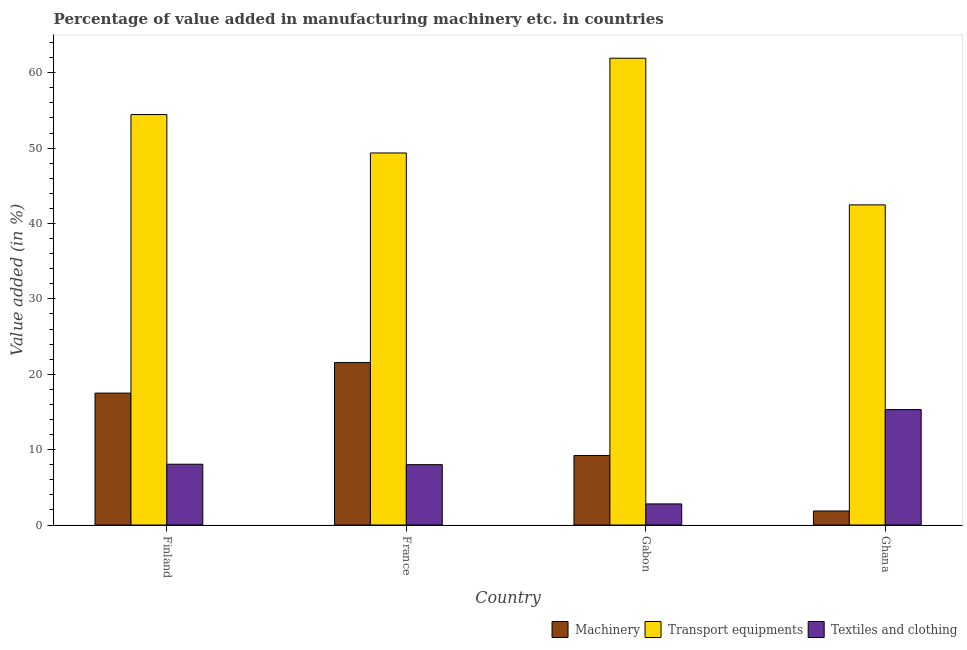Are the number of bars on each tick of the X-axis equal?
Make the answer very short. Yes. How many bars are there on the 2nd tick from the left?
Your answer should be compact. 3. How many bars are there on the 4th tick from the right?
Give a very brief answer. 3. What is the label of the 4th group of bars from the left?
Provide a succinct answer. Ghana. In how many cases, is the number of bars for a given country not equal to the number of legend labels?
Make the answer very short. 0. What is the value added in manufacturing transport equipments in Finland?
Offer a very short reply. 54.45. Across all countries, what is the maximum value added in manufacturing transport equipments?
Your answer should be very brief. 61.93. Across all countries, what is the minimum value added in manufacturing machinery?
Offer a very short reply. 1.86. In which country was the value added in manufacturing machinery maximum?
Keep it short and to the point. France. In which country was the value added in manufacturing machinery minimum?
Provide a short and direct response. Ghana. What is the total value added in manufacturing textile and clothing in the graph?
Your answer should be compact. 34.19. What is the difference between the value added in manufacturing machinery in Finland and that in Gabon?
Offer a very short reply. 8.27. What is the difference between the value added in manufacturing machinery in Gabon and the value added in manufacturing textile and clothing in France?
Give a very brief answer. 1.22. What is the average value added in manufacturing transport equipments per country?
Offer a terse response. 52.05. What is the difference between the value added in manufacturing transport equipments and value added in manufacturing machinery in Gabon?
Your answer should be very brief. 52.7. What is the ratio of the value added in manufacturing transport equipments in Finland to that in Ghana?
Your response must be concise. 1.28. What is the difference between the highest and the second highest value added in manufacturing textile and clothing?
Provide a short and direct response. 7.25. What is the difference between the highest and the lowest value added in manufacturing transport equipments?
Offer a very short reply. 19.46. In how many countries, is the value added in manufacturing transport equipments greater than the average value added in manufacturing transport equipments taken over all countries?
Give a very brief answer. 2. Is the sum of the value added in manufacturing textile and clothing in Finland and Gabon greater than the maximum value added in manufacturing transport equipments across all countries?
Offer a very short reply. No. What does the 2nd bar from the left in France represents?
Provide a succinct answer. Transport equipments. What does the 3rd bar from the right in Ghana represents?
Provide a succinct answer. Machinery. Is it the case that in every country, the sum of the value added in manufacturing machinery and value added in manufacturing transport equipments is greater than the value added in manufacturing textile and clothing?
Ensure brevity in your answer.  Yes. How many bars are there?
Offer a very short reply. 12. How many countries are there in the graph?
Your answer should be compact. 4. Are the values on the major ticks of Y-axis written in scientific E-notation?
Your answer should be compact. No. How many legend labels are there?
Offer a very short reply. 3. How are the legend labels stacked?
Give a very brief answer. Horizontal. What is the title of the graph?
Make the answer very short. Percentage of value added in manufacturing machinery etc. in countries. Does "Neonatal" appear as one of the legend labels in the graph?
Keep it short and to the point. No. What is the label or title of the X-axis?
Your answer should be very brief. Country. What is the label or title of the Y-axis?
Your answer should be compact. Value added (in %). What is the Value added (in %) in Machinery in Finland?
Ensure brevity in your answer.  17.5. What is the Value added (in %) in Transport equipments in Finland?
Give a very brief answer. 54.45. What is the Value added (in %) in Textiles and clothing in Finland?
Your response must be concise. 8.07. What is the Value added (in %) of Machinery in France?
Ensure brevity in your answer.  21.55. What is the Value added (in %) in Transport equipments in France?
Give a very brief answer. 49.36. What is the Value added (in %) in Textiles and clothing in France?
Offer a terse response. 8.01. What is the Value added (in %) of Machinery in Gabon?
Give a very brief answer. 9.23. What is the Value added (in %) of Transport equipments in Gabon?
Your answer should be compact. 61.93. What is the Value added (in %) in Textiles and clothing in Gabon?
Provide a succinct answer. 2.8. What is the Value added (in %) of Machinery in Ghana?
Offer a very short reply. 1.86. What is the Value added (in %) in Transport equipments in Ghana?
Offer a terse response. 42.47. What is the Value added (in %) in Textiles and clothing in Ghana?
Your answer should be compact. 15.31. Across all countries, what is the maximum Value added (in %) in Machinery?
Make the answer very short. 21.55. Across all countries, what is the maximum Value added (in %) in Transport equipments?
Offer a very short reply. 61.93. Across all countries, what is the maximum Value added (in %) in Textiles and clothing?
Provide a short and direct response. 15.31. Across all countries, what is the minimum Value added (in %) of Machinery?
Keep it short and to the point. 1.86. Across all countries, what is the minimum Value added (in %) of Transport equipments?
Your response must be concise. 42.47. Across all countries, what is the minimum Value added (in %) of Textiles and clothing?
Your answer should be very brief. 2.8. What is the total Value added (in %) in Machinery in the graph?
Your response must be concise. 50.14. What is the total Value added (in %) in Transport equipments in the graph?
Your answer should be very brief. 208.21. What is the total Value added (in %) in Textiles and clothing in the graph?
Offer a terse response. 34.19. What is the difference between the Value added (in %) in Machinery in Finland and that in France?
Provide a succinct answer. -4.05. What is the difference between the Value added (in %) in Transport equipments in Finland and that in France?
Provide a short and direct response. 5.1. What is the difference between the Value added (in %) in Textiles and clothing in Finland and that in France?
Your answer should be very brief. 0.06. What is the difference between the Value added (in %) in Machinery in Finland and that in Gabon?
Offer a terse response. 8.27. What is the difference between the Value added (in %) in Transport equipments in Finland and that in Gabon?
Your answer should be compact. -7.47. What is the difference between the Value added (in %) in Textiles and clothing in Finland and that in Gabon?
Give a very brief answer. 5.27. What is the difference between the Value added (in %) in Machinery in Finland and that in Ghana?
Provide a succinct answer. 15.64. What is the difference between the Value added (in %) of Transport equipments in Finland and that in Ghana?
Ensure brevity in your answer.  11.98. What is the difference between the Value added (in %) of Textiles and clothing in Finland and that in Ghana?
Provide a succinct answer. -7.25. What is the difference between the Value added (in %) in Machinery in France and that in Gabon?
Offer a very short reply. 12.32. What is the difference between the Value added (in %) in Transport equipments in France and that in Gabon?
Provide a short and direct response. -12.57. What is the difference between the Value added (in %) of Textiles and clothing in France and that in Gabon?
Your answer should be very brief. 5.21. What is the difference between the Value added (in %) of Machinery in France and that in Ghana?
Provide a short and direct response. 19.69. What is the difference between the Value added (in %) of Transport equipments in France and that in Ghana?
Provide a short and direct response. 6.89. What is the difference between the Value added (in %) of Textiles and clothing in France and that in Ghana?
Provide a succinct answer. -7.3. What is the difference between the Value added (in %) in Machinery in Gabon and that in Ghana?
Your answer should be compact. 7.37. What is the difference between the Value added (in %) of Transport equipments in Gabon and that in Ghana?
Offer a very short reply. 19.46. What is the difference between the Value added (in %) of Textiles and clothing in Gabon and that in Ghana?
Keep it short and to the point. -12.51. What is the difference between the Value added (in %) in Machinery in Finland and the Value added (in %) in Transport equipments in France?
Give a very brief answer. -31.86. What is the difference between the Value added (in %) in Machinery in Finland and the Value added (in %) in Textiles and clothing in France?
Provide a short and direct response. 9.49. What is the difference between the Value added (in %) of Transport equipments in Finland and the Value added (in %) of Textiles and clothing in France?
Offer a very short reply. 46.45. What is the difference between the Value added (in %) of Machinery in Finland and the Value added (in %) of Transport equipments in Gabon?
Provide a succinct answer. -44.43. What is the difference between the Value added (in %) of Machinery in Finland and the Value added (in %) of Textiles and clothing in Gabon?
Make the answer very short. 14.7. What is the difference between the Value added (in %) in Transport equipments in Finland and the Value added (in %) in Textiles and clothing in Gabon?
Your response must be concise. 51.65. What is the difference between the Value added (in %) of Machinery in Finland and the Value added (in %) of Transport equipments in Ghana?
Your answer should be very brief. -24.97. What is the difference between the Value added (in %) of Machinery in Finland and the Value added (in %) of Textiles and clothing in Ghana?
Provide a succinct answer. 2.19. What is the difference between the Value added (in %) of Transport equipments in Finland and the Value added (in %) of Textiles and clothing in Ghana?
Give a very brief answer. 39.14. What is the difference between the Value added (in %) of Machinery in France and the Value added (in %) of Transport equipments in Gabon?
Your answer should be very brief. -40.38. What is the difference between the Value added (in %) in Machinery in France and the Value added (in %) in Textiles and clothing in Gabon?
Provide a short and direct response. 18.75. What is the difference between the Value added (in %) of Transport equipments in France and the Value added (in %) of Textiles and clothing in Gabon?
Ensure brevity in your answer.  46.56. What is the difference between the Value added (in %) of Machinery in France and the Value added (in %) of Transport equipments in Ghana?
Give a very brief answer. -20.92. What is the difference between the Value added (in %) in Machinery in France and the Value added (in %) in Textiles and clothing in Ghana?
Provide a succinct answer. 6.24. What is the difference between the Value added (in %) in Transport equipments in France and the Value added (in %) in Textiles and clothing in Ghana?
Your answer should be very brief. 34.05. What is the difference between the Value added (in %) in Machinery in Gabon and the Value added (in %) in Transport equipments in Ghana?
Keep it short and to the point. -33.24. What is the difference between the Value added (in %) in Machinery in Gabon and the Value added (in %) in Textiles and clothing in Ghana?
Provide a succinct answer. -6.08. What is the difference between the Value added (in %) in Transport equipments in Gabon and the Value added (in %) in Textiles and clothing in Ghana?
Make the answer very short. 46.61. What is the average Value added (in %) in Machinery per country?
Offer a terse response. 12.54. What is the average Value added (in %) of Transport equipments per country?
Offer a terse response. 52.05. What is the average Value added (in %) in Textiles and clothing per country?
Make the answer very short. 8.55. What is the difference between the Value added (in %) of Machinery and Value added (in %) of Transport equipments in Finland?
Offer a very short reply. -36.95. What is the difference between the Value added (in %) of Machinery and Value added (in %) of Textiles and clothing in Finland?
Provide a succinct answer. 9.44. What is the difference between the Value added (in %) in Transport equipments and Value added (in %) in Textiles and clothing in Finland?
Provide a succinct answer. 46.39. What is the difference between the Value added (in %) of Machinery and Value added (in %) of Transport equipments in France?
Give a very brief answer. -27.81. What is the difference between the Value added (in %) of Machinery and Value added (in %) of Textiles and clothing in France?
Offer a terse response. 13.54. What is the difference between the Value added (in %) in Transport equipments and Value added (in %) in Textiles and clothing in France?
Your answer should be compact. 41.35. What is the difference between the Value added (in %) in Machinery and Value added (in %) in Transport equipments in Gabon?
Your response must be concise. -52.7. What is the difference between the Value added (in %) in Machinery and Value added (in %) in Textiles and clothing in Gabon?
Give a very brief answer. 6.43. What is the difference between the Value added (in %) of Transport equipments and Value added (in %) of Textiles and clothing in Gabon?
Offer a terse response. 59.13. What is the difference between the Value added (in %) of Machinery and Value added (in %) of Transport equipments in Ghana?
Offer a very short reply. -40.61. What is the difference between the Value added (in %) in Machinery and Value added (in %) in Textiles and clothing in Ghana?
Offer a terse response. -13.45. What is the difference between the Value added (in %) in Transport equipments and Value added (in %) in Textiles and clothing in Ghana?
Provide a succinct answer. 27.16. What is the ratio of the Value added (in %) in Machinery in Finland to that in France?
Your answer should be compact. 0.81. What is the ratio of the Value added (in %) in Transport equipments in Finland to that in France?
Make the answer very short. 1.1. What is the ratio of the Value added (in %) in Textiles and clothing in Finland to that in France?
Make the answer very short. 1.01. What is the ratio of the Value added (in %) of Machinery in Finland to that in Gabon?
Provide a succinct answer. 1.9. What is the ratio of the Value added (in %) in Transport equipments in Finland to that in Gabon?
Offer a very short reply. 0.88. What is the ratio of the Value added (in %) of Textiles and clothing in Finland to that in Gabon?
Ensure brevity in your answer.  2.88. What is the ratio of the Value added (in %) in Machinery in Finland to that in Ghana?
Keep it short and to the point. 9.4. What is the ratio of the Value added (in %) in Transport equipments in Finland to that in Ghana?
Your answer should be very brief. 1.28. What is the ratio of the Value added (in %) of Textiles and clothing in Finland to that in Ghana?
Keep it short and to the point. 0.53. What is the ratio of the Value added (in %) of Machinery in France to that in Gabon?
Offer a terse response. 2.34. What is the ratio of the Value added (in %) in Transport equipments in France to that in Gabon?
Make the answer very short. 0.8. What is the ratio of the Value added (in %) of Textiles and clothing in France to that in Gabon?
Make the answer very short. 2.86. What is the ratio of the Value added (in %) in Machinery in France to that in Ghana?
Your response must be concise. 11.57. What is the ratio of the Value added (in %) of Transport equipments in France to that in Ghana?
Make the answer very short. 1.16. What is the ratio of the Value added (in %) of Textiles and clothing in France to that in Ghana?
Offer a very short reply. 0.52. What is the ratio of the Value added (in %) in Machinery in Gabon to that in Ghana?
Your answer should be very brief. 4.96. What is the ratio of the Value added (in %) of Transport equipments in Gabon to that in Ghana?
Provide a succinct answer. 1.46. What is the ratio of the Value added (in %) of Textiles and clothing in Gabon to that in Ghana?
Ensure brevity in your answer.  0.18. What is the difference between the highest and the second highest Value added (in %) of Machinery?
Your answer should be compact. 4.05. What is the difference between the highest and the second highest Value added (in %) of Transport equipments?
Keep it short and to the point. 7.47. What is the difference between the highest and the second highest Value added (in %) in Textiles and clothing?
Your response must be concise. 7.25. What is the difference between the highest and the lowest Value added (in %) of Machinery?
Provide a succinct answer. 19.69. What is the difference between the highest and the lowest Value added (in %) of Transport equipments?
Your answer should be compact. 19.46. What is the difference between the highest and the lowest Value added (in %) in Textiles and clothing?
Offer a terse response. 12.51. 